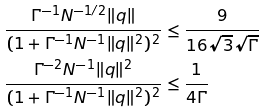Convert formula to latex. <formula><loc_0><loc_0><loc_500><loc_500>\frac { \Gamma ^ { - 1 } N ^ { - 1 / 2 } \| q \| } { ( 1 + \Gamma ^ { - 1 } N ^ { - 1 } \| q \| ^ { 2 } ) ^ { 2 } } & \leq \frac { 9 } { 1 6 \sqrt { 3 } \sqrt { \Gamma } } \\ \frac { \Gamma ^ { - 2 } N ^ { - 1 } \| q \| ^ { 2 } } { ( 1 + \Gamma ^ { - 1 } N ^ { - 1 } \| q \| ^ { 2 } ) ^ { 2 } } & \leq \frac { 1 } { 4 \Gamma }</formula> 